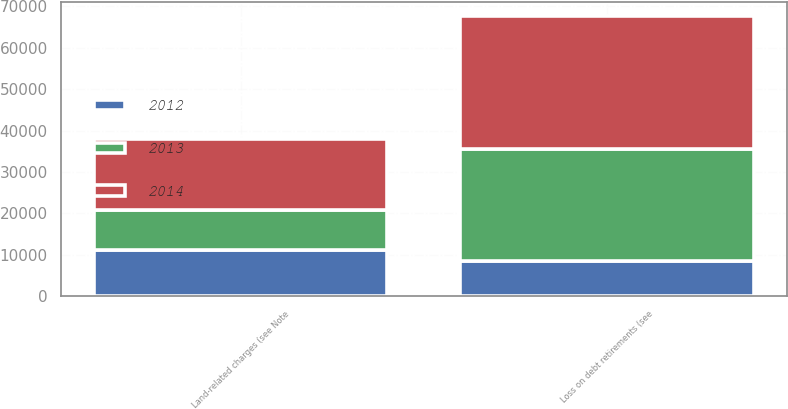Convert chart. <chart><loc_0><loc_0><loc_500><loc_500><stacked_bar_chart><ecel><fcel>Land-related charges (see Note<fcel>Loss on debt retirements (see<nl><fcel>2012<fcel>11168<fcel>8584<nl><fcel>2013<fcel>9672<fcel>26930<nl><fcel>2014<fcel>17195<fcel>32071<nl></chart> 